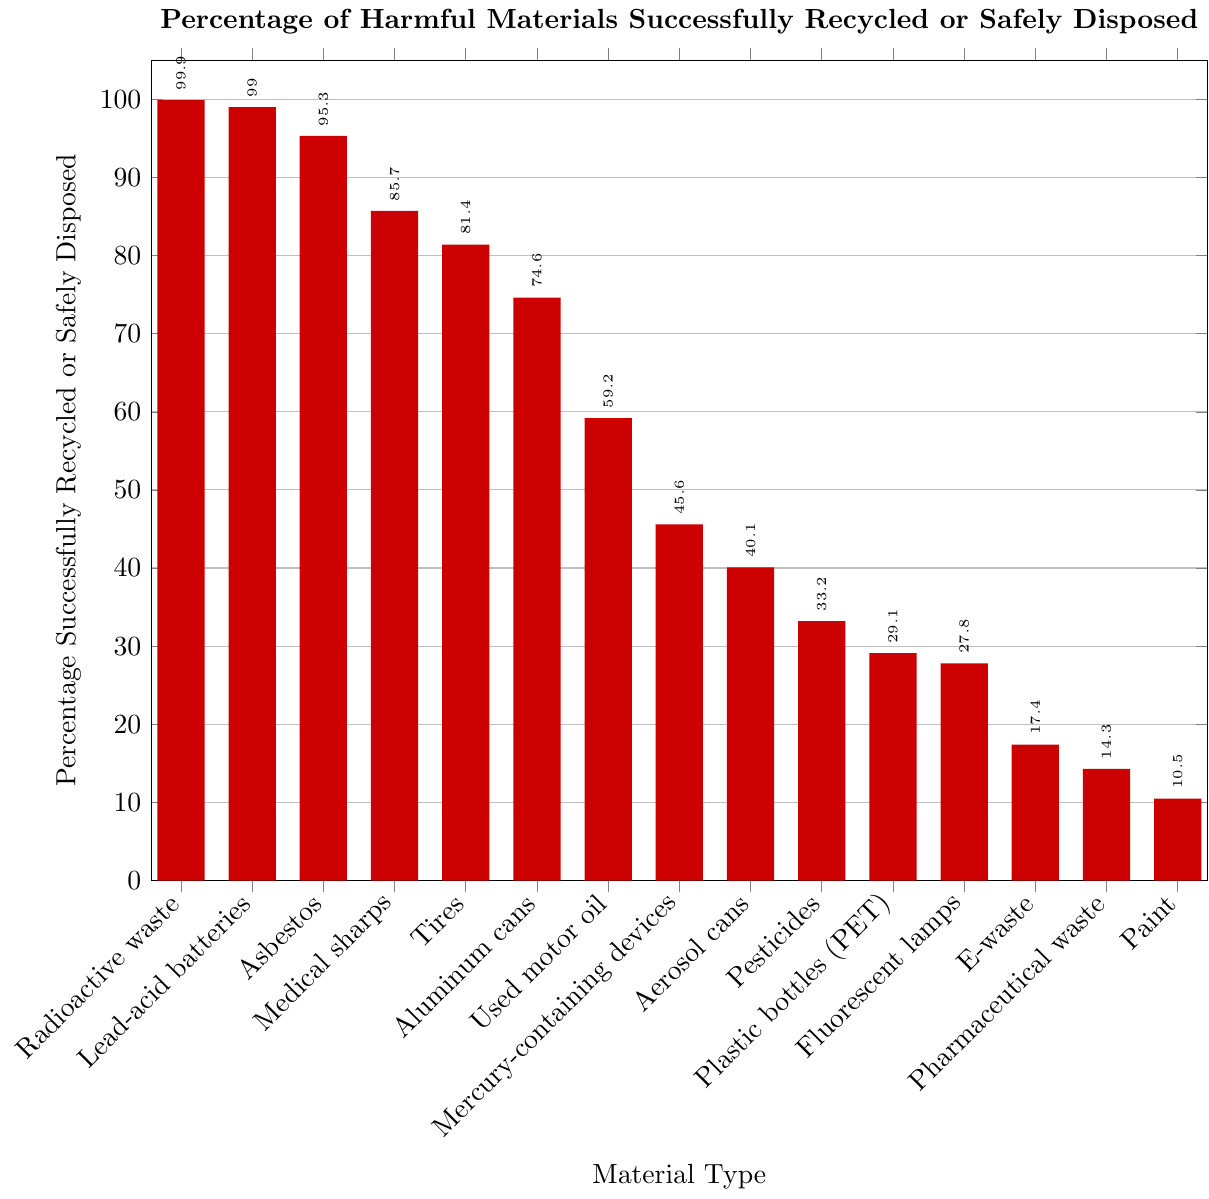Which material type has the highest percentage of successful recycling or safe disposal? By examining the heights of the bars in the figure, we see that the tallest bar corresponds to radioactive waste. Thus, radioactive waste has the highest percentage.
Answer: Radioactive waste Which material type has the lowest percentage of successful recycling or safe disposal? By looking at the shortest bar in the figure, we see it corresponds to paint. Thus, paint has the lowest percentage.
Answer: Paint What is the combined percentage of successful recycling or safe disposal for Asbestos and Medical sharps? The figure shows that Asbestos has a percentage of 95.3 and Medical sharps have 85.7. Summing these percentages gives 95.3 + 85.7.
Answer: 181 How many material types have a recycling or safe disposal percentage greater than 50%? By visually inspecting and counting the bars higher than the 50% mark, the material types are Lead-acid batteries, Aluminum cans, Used motor oil, Asbestos, Medical sharps, and Tires.
Answer: 6 Which material types have percentages between 20% and 40%? Examining the figure, the bars between 20% and 40% correspond to Fluorescent lamps, Pesticides, Aerosol cans, and Plastic bottles (PET).
Answer: Fluorescent lamps, Pesticides, Aerosol cans, Plastic bottles (PET) How much higher is the recycling or safe disposal percentage of Lead-acid batteries compared to Plastic bottles (PET)? Lead-acid batteries have a percentage of 99.0 and Plastic bottles have 29.1. The difference is calculated by 99.0 - 29.1.
Answer: 69.9 List the colors used for the bars representing Lead-acid batteries and Aluminum cans. The bar for Lead-acid batteries is shaded in orange and the bar for Aluminum cans is shaded in violet.
Answer: Orange, Violet What is the average recycling or safe disposal percentage for E-waste, Pharmaceutical waste, and Paint? Adding the percentages for E-waste (17.4), Pharmaceutical waste (14.3), and Paint (10.5) results in a sum of 17.4 + 14.3 + 10.5 = 42.2. Dividing by 3 gives the average: 42.2 / 3.
Answer: 14.07 Between Used motor oil and Mercury-containing devices, which material type has a higher percentage? By checking the figure, Used motor oil is at 59.2 and Mercury-containing devices are at 45.6. Thus, Used motor oil has the higher percentage.
Answer: Used motor oil What is the median percentage of all material types listed? Ordering the values: 10.5, 14.3, 17.4, 27.8, 29.1, 33.2, 40.1, 45.6, 59.2, 74.6, 81.4, 85.7, 95.3, 99.0, 99.9, the median value is the eighth value in the ordered list, which is 45.6.
Answer: 45.6 